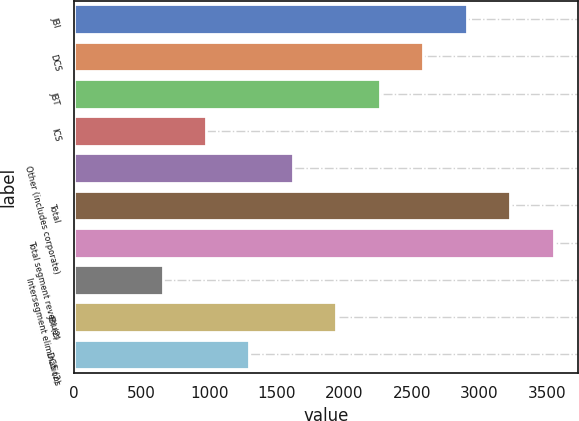Convert chart to OTSL. <chart><loc_0><loc_0><loc_500><loc_500><bar_chart><fcel>JBI<fcel>DCS<fcel>JBT<fcel>ICS<fcel>Other (includes corporate)<fcel>Total<fcel>Total segment revenues<fcel>Intersegment eliminations<fcel>JBI (2)<fcel>DCS (2)<nl><fcel>2905.4<fcel>2583.8<fcel>2262.2<fcel>975.8<fcel>1619<fcel>3227<fcel>3548.6<fcel>654.2<fcel>1940.6<fcel>1297.4<nl></chart> 